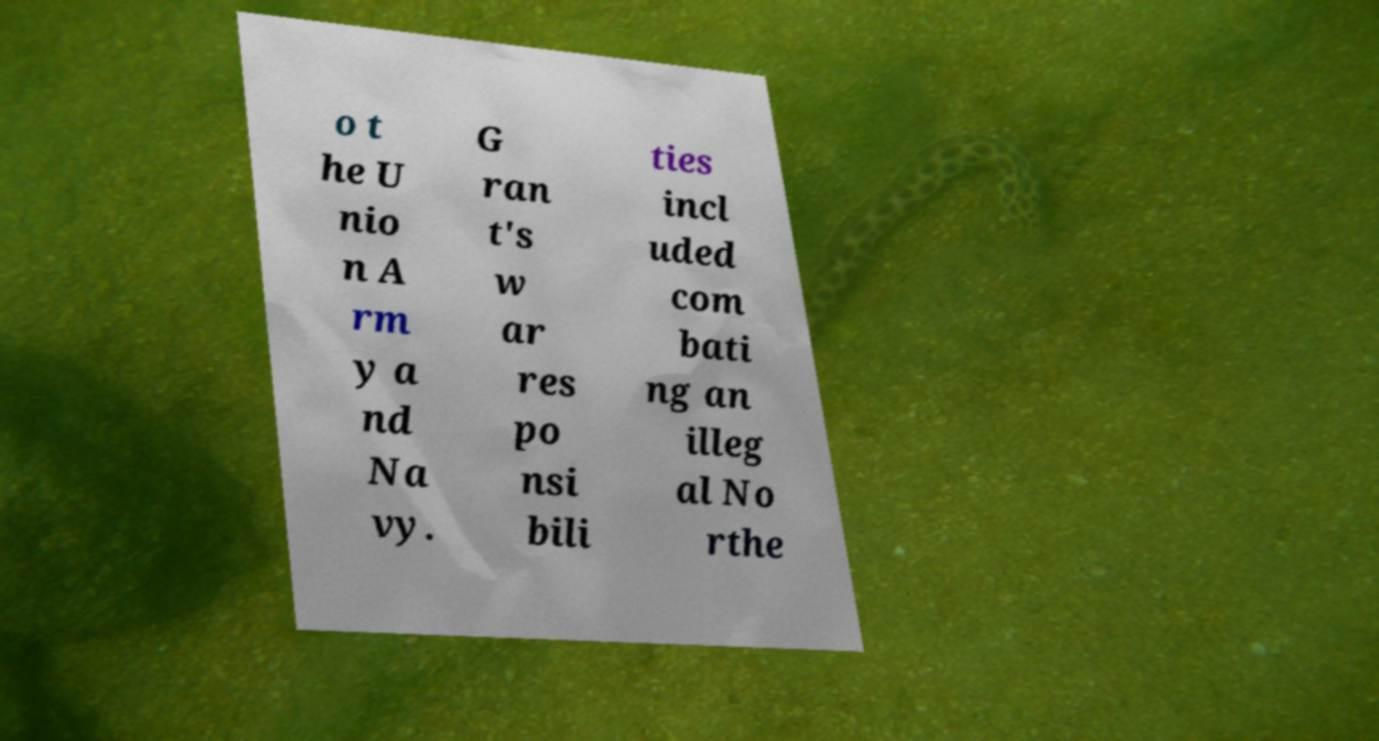There's text embedded in this image that I need extracted. Can you transcribe it verbatim? o t he U nio n A rm y a nd Na vy. G ran t's w ar res po nsi bili ties incl uded com bati ng an illeg al No rthe 